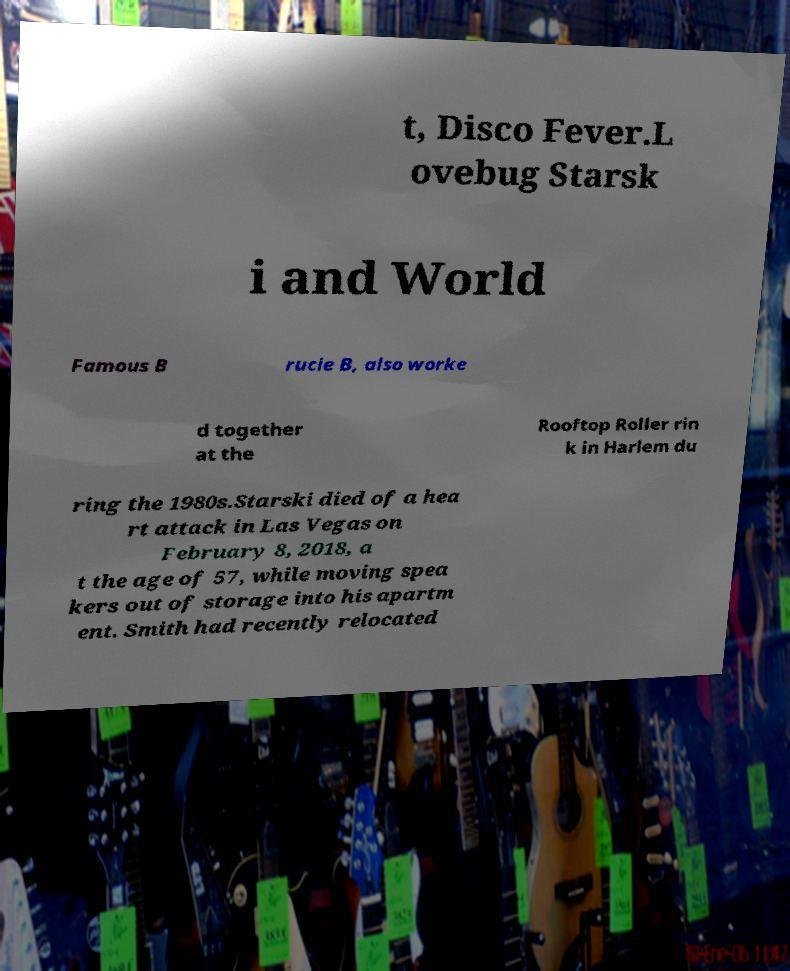Please identify and transcribe the text found in this image. t, Disco Fever.L ovebug Starsk i and World Famous B rucie B, also worke d together at the Rooftop Roller rin k in Harlem du ring the 1980s.Starski died of a hea rt attack in Las Vegas on February 8, 2018, a t the age of 57, while moving spea kers out of storage into his apartm ent. Smith had recently relocated 